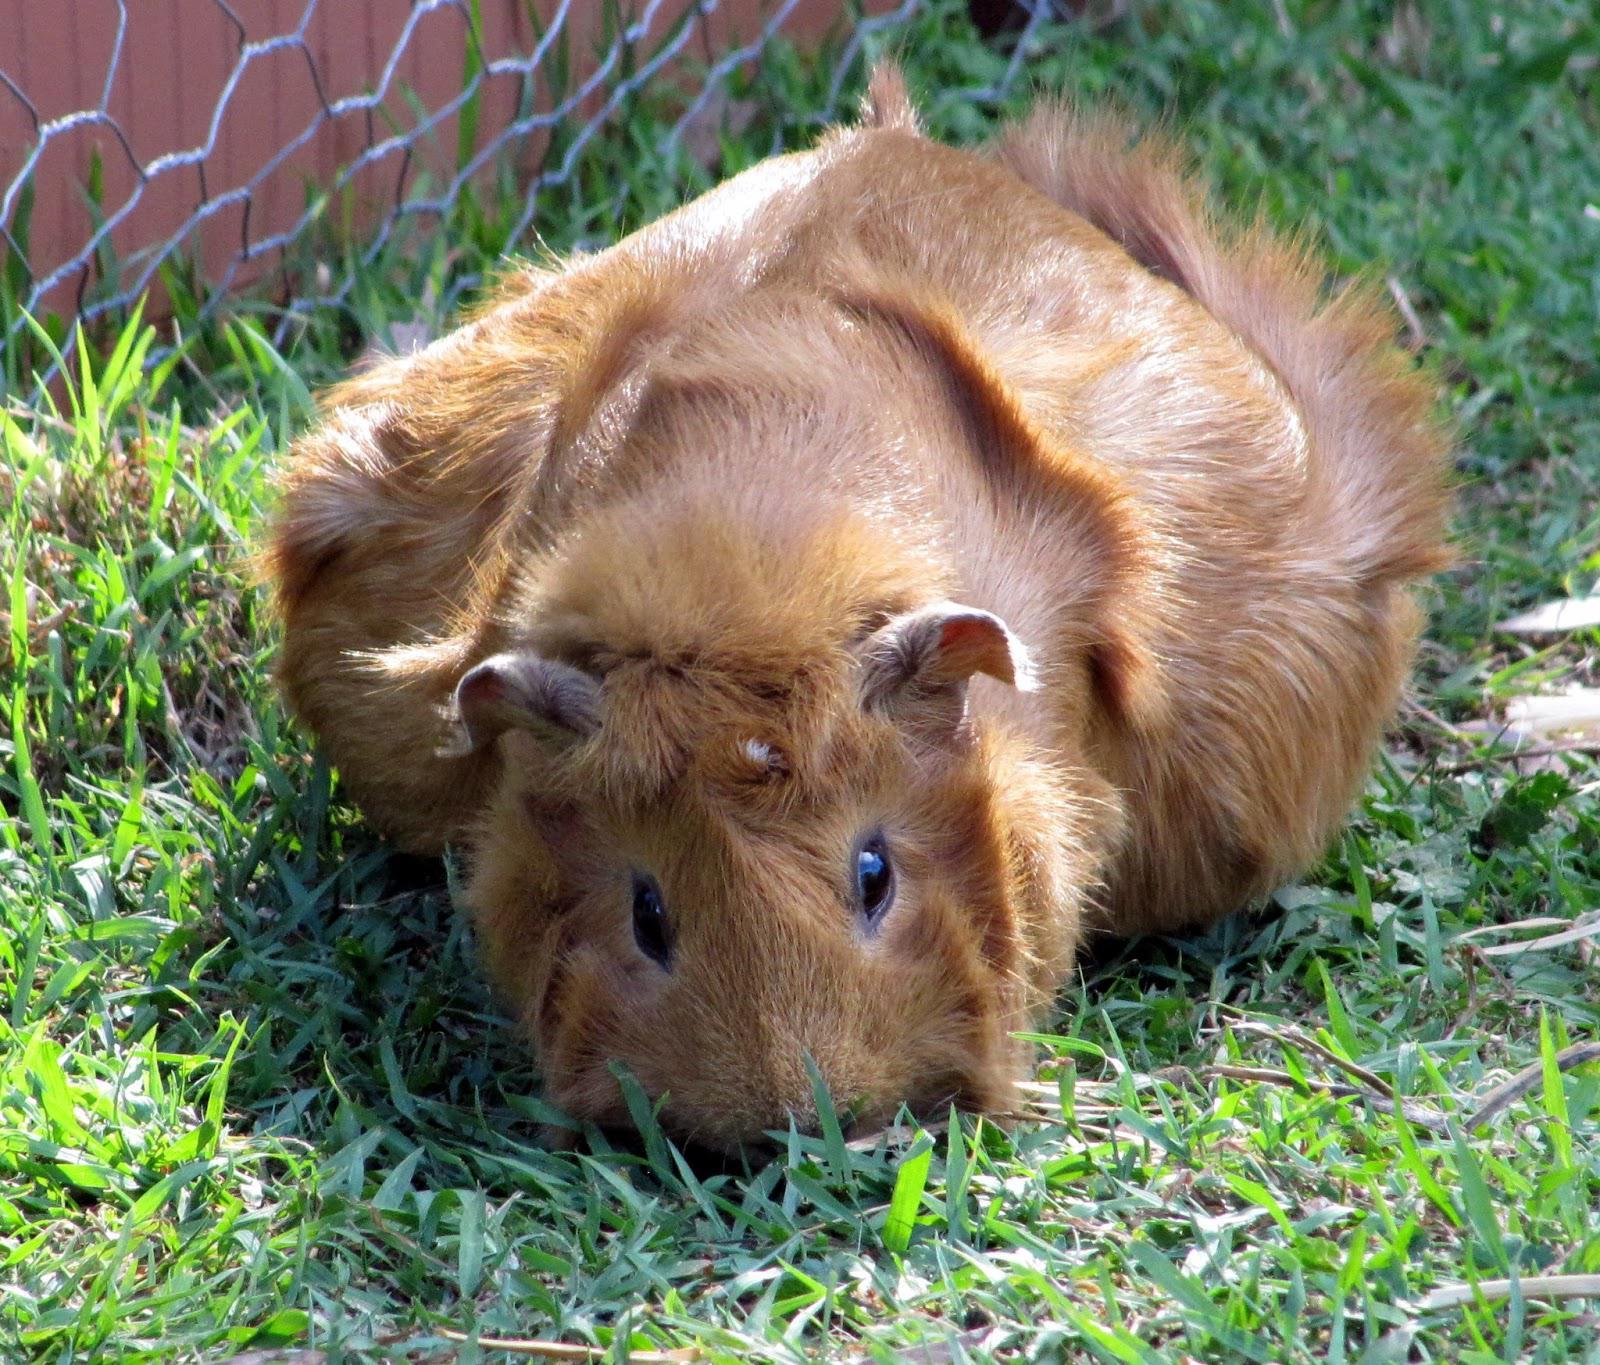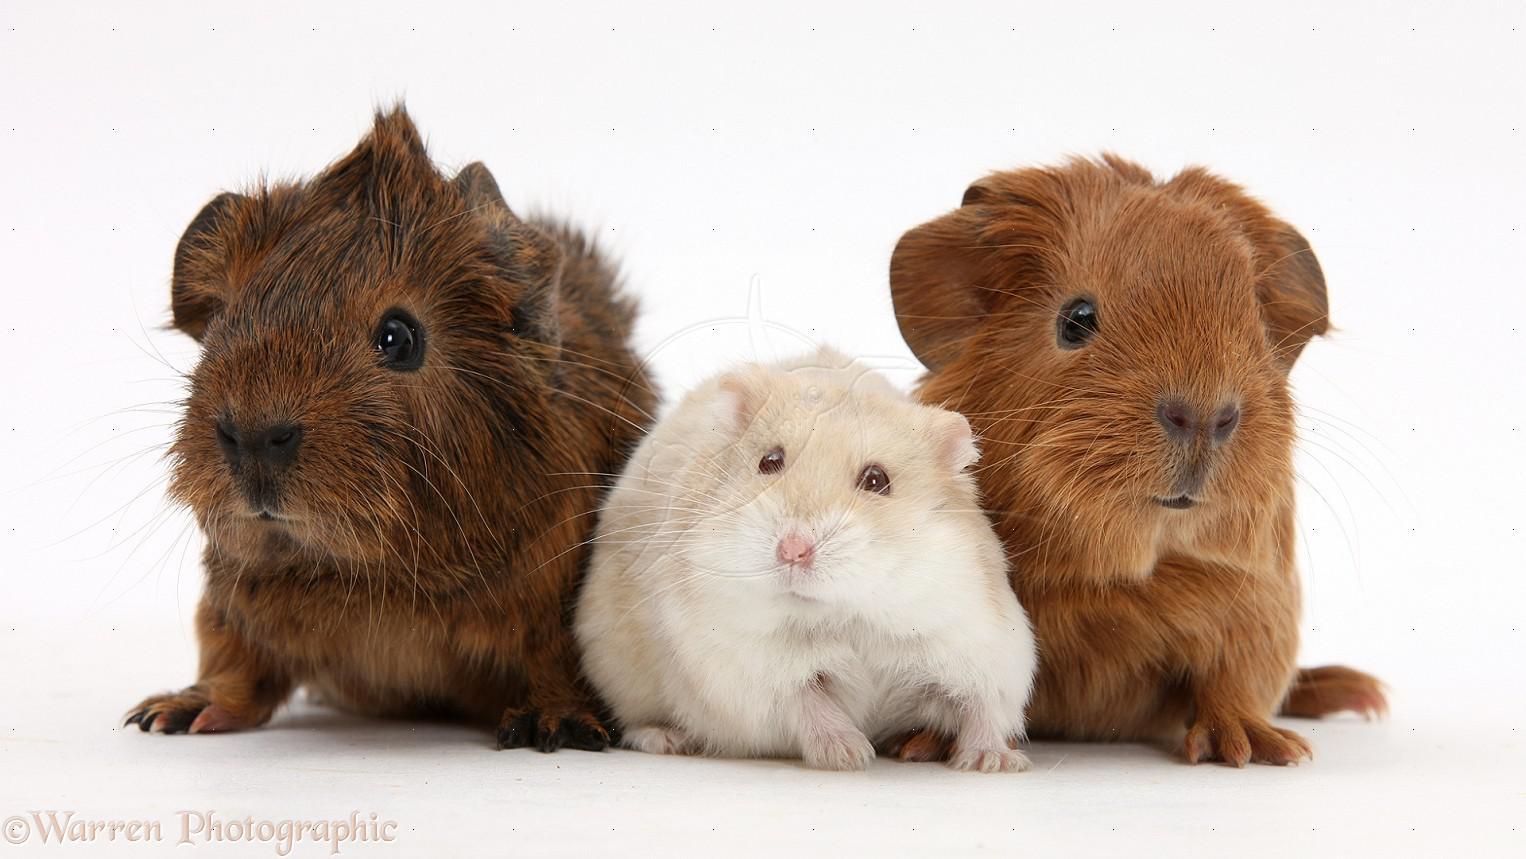The first image is the image on the left, the second image is the image on the right. Analyze the images presented: Is the assertion "There are 6 guinea pigs in all, the three in the image on the right are lined up side by side, looking at the camera." valid? Answer yes or no. No. The first image is the image on the left, the second image is the image on the right. Given the left and right images, does the statement "An image shows three multicolor guinea pigs posed side-by-side outdoors with greenery in the picture." hold true? Answer yes or no. No. 